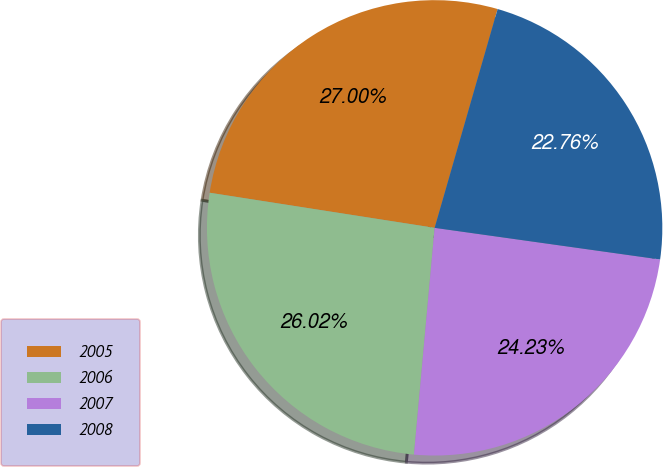Convert chart to OTSL. <chart><loc_0><loc_0><loc_500><loc_500><pie_chart><fcel>2005<fcel>2006<fcel>2007<fcel>2008<nl><fcel>27.0%<fcel>26.02%<fcel>24.23%<fcel>22.76%<nl></chart> 